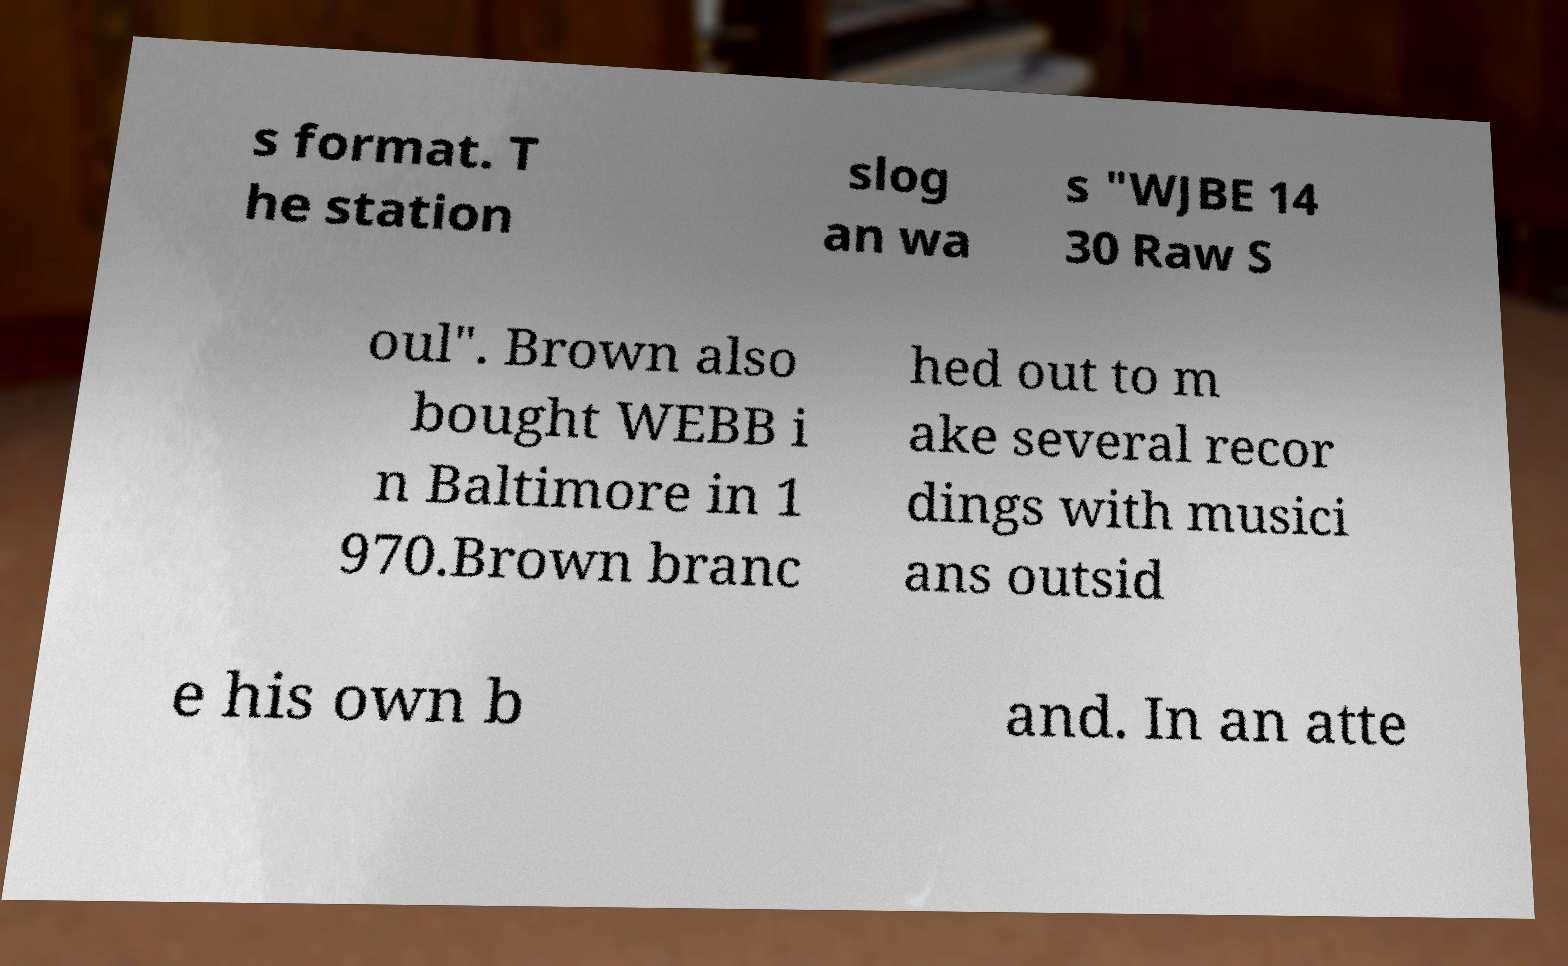There's text embedded in this image that I need extracted. Can you transcribe it verbatim? s format. T he station slog an wa s "WJBE 14 30 Raw S oul". Brown also bought WEBB i n Baltimore in 1 970.Brown branc hed out to m ake several recor dings with musici ans outsid e his own b and. In an atte 